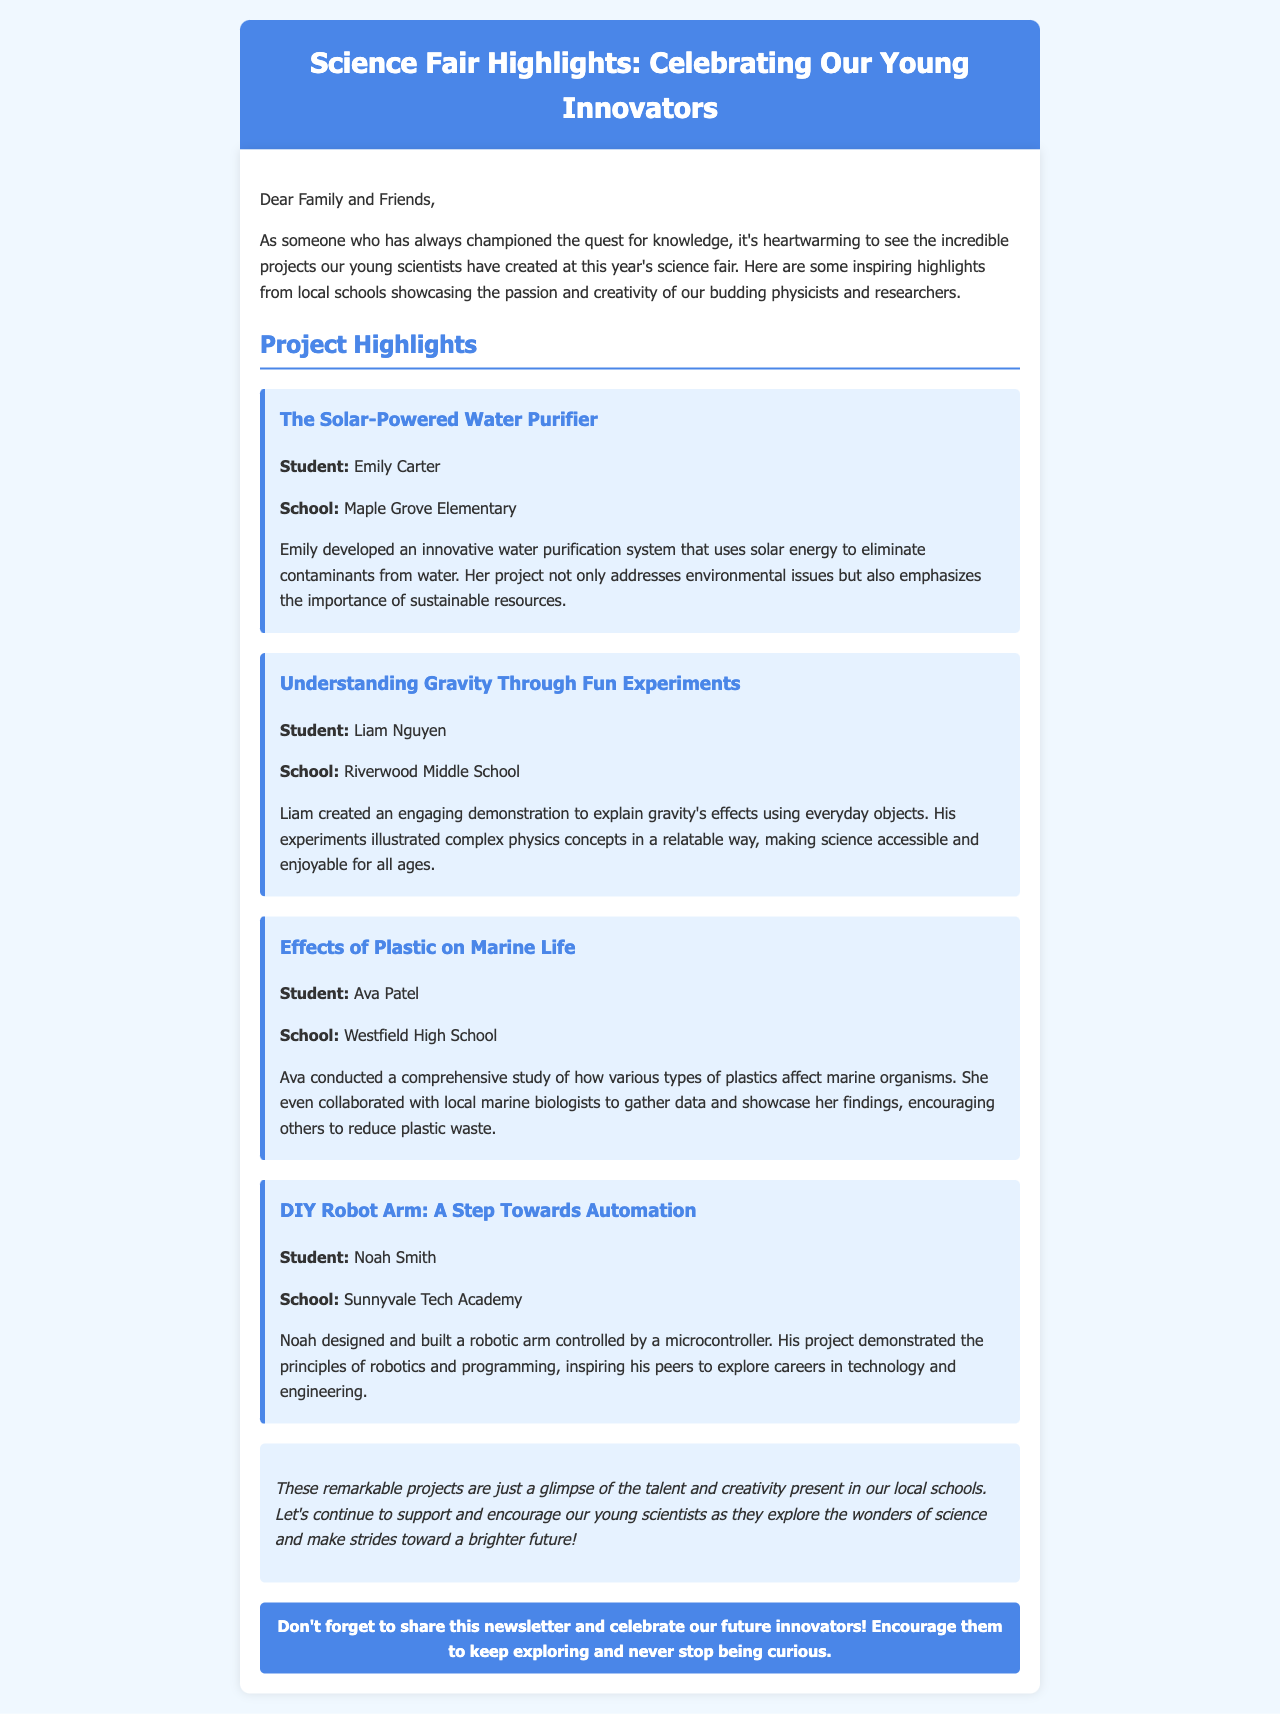what is the name of the first project listed? The first project is "The Solar-Powered Water Purifier," which is the title mentioned in the highlights.
Answer: The Solar-Powered Water Purifier who is the student behind the project on gravity? The project titled "Understanding Gravity Through Fun Experiments" is created by Liam Nguyen, as stated in the document.
Answer: Liam Nguyen which school did Ava Patel attend? Ava Patel's school is mentioned as Westfield High School in her project details.
Answer: Westfield High School how many projects are highlighted in total? The document lists four different projects showcasing young scientists' work, thus summing them up gives four projects.
Answer: Four what subject does Noah Smith’s project focus on? Noah's project titled "DIY Robot Arm: A Step Towards Automation" focuses on robotics, showcasing its principles and programming.
Answer: Robotics what main theme connects all the projects presented? Each project emphasizes environmental issues, scientific principles, or technological advancement, thus linking them through innovation and sustainability.
Answer: Innovation and sustainability which project involved collaboration with local marine biologists? The project "Effects of Plastic on Marine Life" featured collaboration with local marine biologists to gather data for the study.
Answer: Effects of Plastic on Marine Life what call to action is mentioned in the newsletter? The newsletter encourages readers to share it and support future innovators in their scientific pursuits.
Answer: Share this newsletter and celebrate our future innovators! 